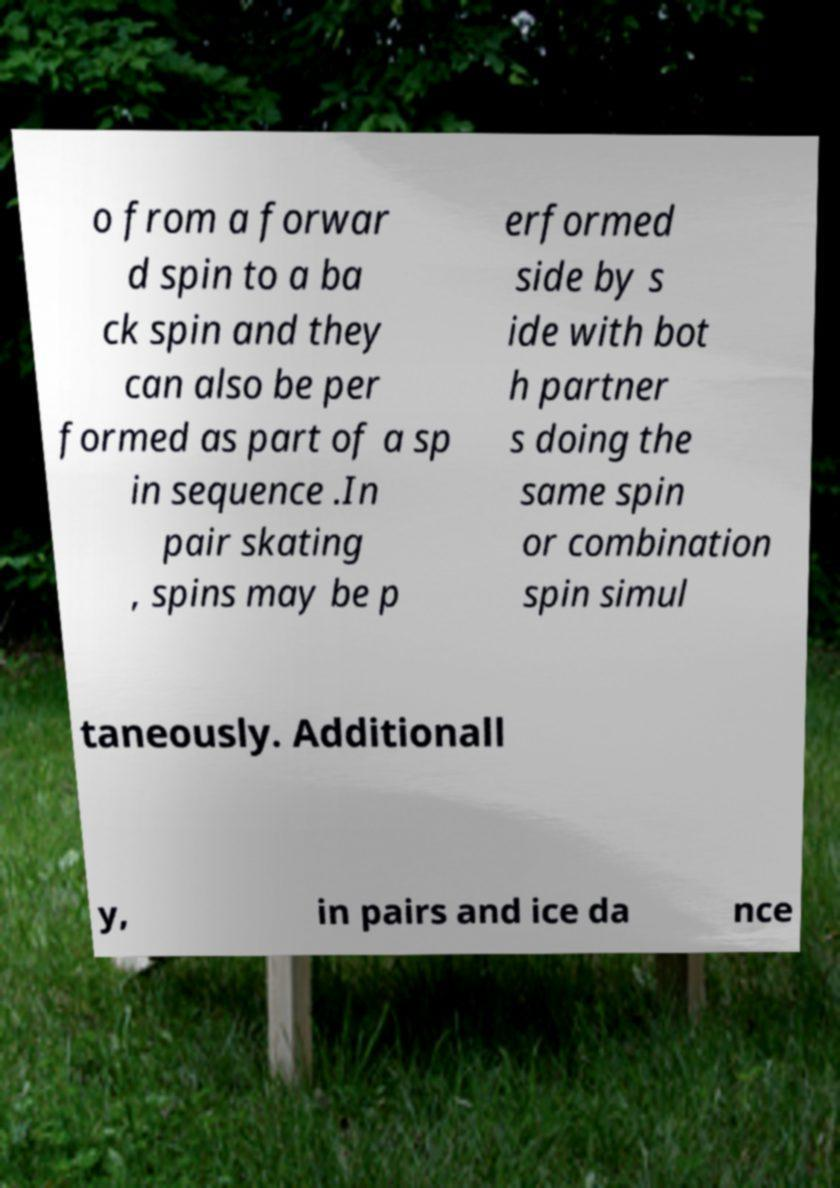Could you assist in decoding the text presented in this image and type it out clearly? o from a forwar d spin to a ba ck spin and they can also be per formed as part of a sp in sequence .In pair skating , spins may be p erformed side by s ide with bot h partner s doing the same spin or combination spin simul taneously. Additionall y, in pairs and ice da nce 